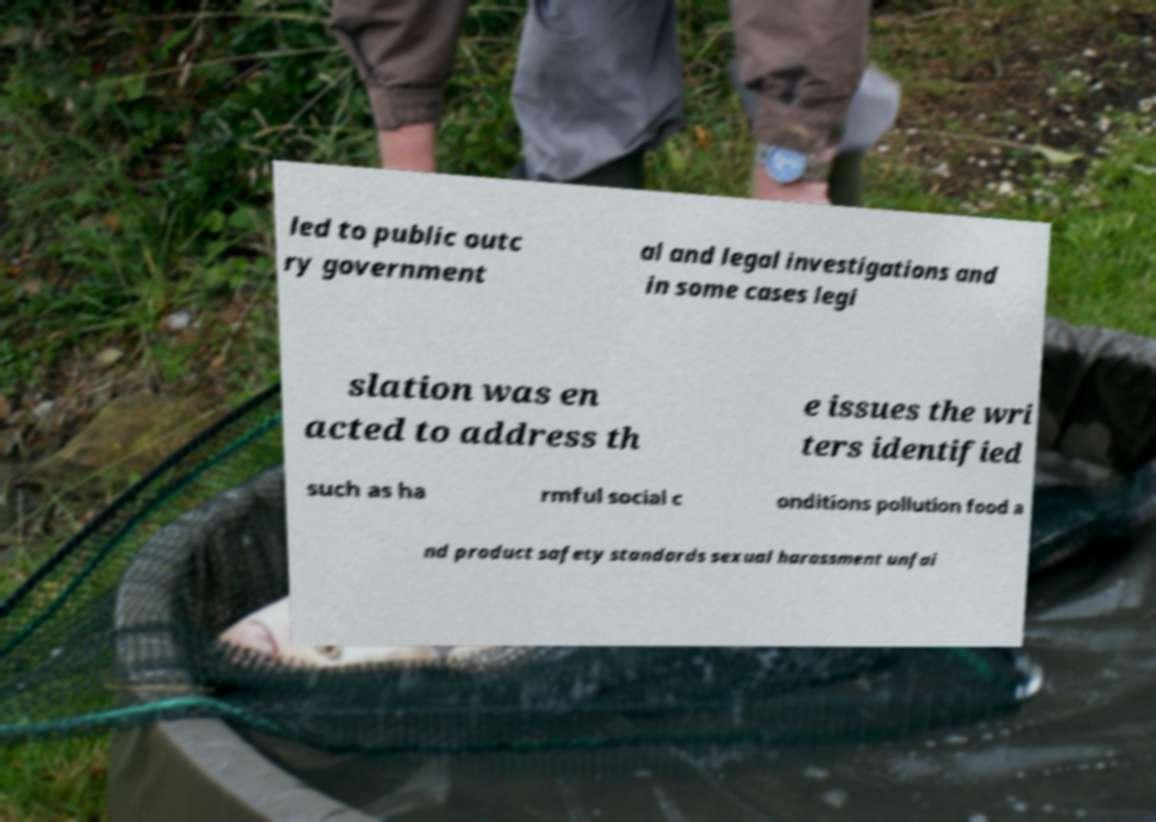Can you accurately transcribe the text from the provided image for me? led to public outc ry government al and legal investigations and in some cases legi slation was en acted to address th e issues the wri ters identified such as ha rmful social c onditions pollution food a nd product safety standards sexual harassment unfai 